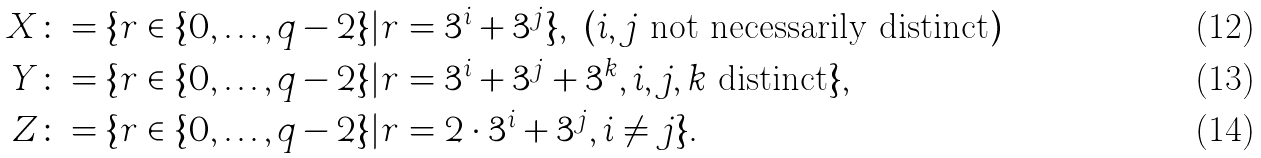<formula> <loc_0><loc_0><loc_500><loc_500>X & \colon = \{ r \in \{ 0 , \dots , q - 2 \} | r = 3 ^ { i } + 3 ^ { j } \} , \ ( i , j \text { not necessarily distinct} ) \\ Y & \colon = \{ r \in \{ 0 , \dots , q - 2 \} | r = 3 ^ { i } + 3 ^ { j } + 3 ^ { k } , i , j , k \text { distinct} \} , \\ Z & \colon = \{ r \in \{ 0 , \dots , q - 2 \} | r = 2 \cdot 3 ^ { i } + 3 ^ { j } , i \ne j \} .</formula> 